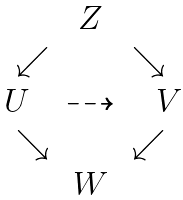Convert formula to latex. <formula><loc_0><loc_0><loc_500><loc_500>\begin{matrix} & Z & \\ \quad \swarrow & & \searrow \quad \\ U & \dashrightarrow & \ V \\ { \quad \searrow } & \ & { \swarrow } \quad \\ \ & W & \end{matrix}</formula> 